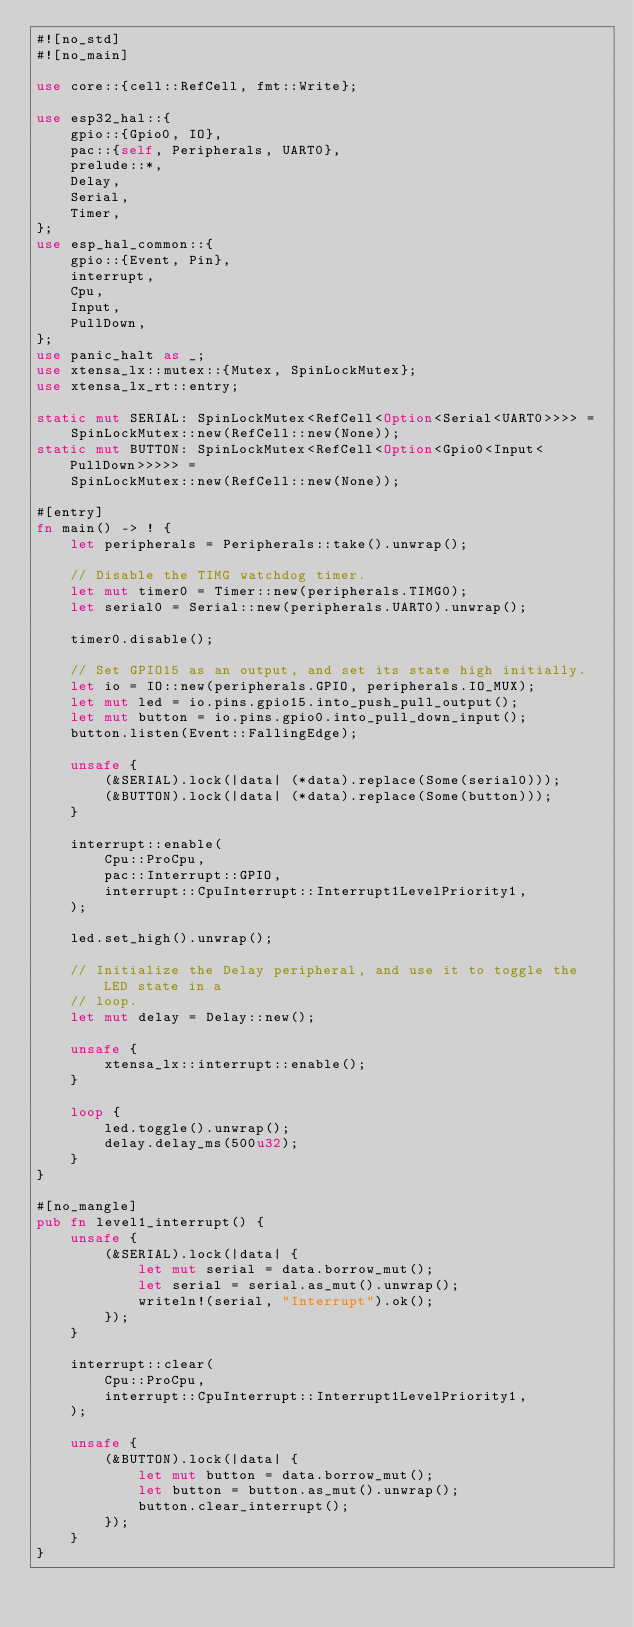<code> <loc_0><loc_0><loc_500><loc_500><_Rust_>#![no_std]
#![no_main]

use core::{cell::RefCell, fmt::Write};

use esp32_hal::{
    gpio::{Gpio0, IO},
    pac::{self, Peripherals, UART0},
    prelude::*,
    Delay,
    Serial,
    Timer,
};
use esp_hal_common::{
    gpio::{Event, Pin},
    interrupt,
    Cpu,
    Input,
    PullDown,
};
use panic_halt as _;
use xtensa_lx::mutex::{Mutex, SpinLockMutex};
use xtensa_lx_rt::entry;

static mut SERIAL: SpinLockMutex<RefCell<Option<Serial<UART0>>>> =
    SpinLockMutex::new(RefCell::new(None));
static mut BUTTON: SpinLockMutex<RefCell<Option<Gpio0<Input<PullDown>>>>> =
    SpinLockMutex::new(RefCell::new(None));

#[entry]
fn main() -> ! {
    let peripherals = Peripherals::take().unwrap();

    // Disable the TIMG watchdog timer.
    let mut timer0 = Timer::new(peripherals.TIMG0);
    let serial0 = Serial::new(peripherals.UART0).unwrap();

    timer0.disable();

    // Set GPIO15 as an output, and set its state high initially.
    let io = IO::new(peripherals.GPIO, peripherals.IO_MUX);
    let mut led = io.pins.gpio15.into_push_pull_output();
    let mut button = io.pins.gpio0.into_pull_down_input();
    button.listen(Event::FallingEdge);

    unsafe {
        (&SERIAL).lock(|data| (*data).replace(Some(serial0)));
        (&BUTTON).lock(|data| (*data).replace(Some(button)));
    }

    interrupt::enable(
        Cpu::ProCpu,
        pac::Interrupt::GPIO,
        interrupt::CpuInterrupt::Interrupt1LevelPriority1,
    );

    led.set_high().unwrap();

    // Initialize the Delay peripheral, and use it to toggle the LED state in a
    // loop.
    let mut delay = Delay::new();

    unsafe {
        xtensa_lx::interrupt::enable();
    }

    loop {
        led.toggle().unwrap();
        delay.delay_ms(500u32);
    }
}

#[no_mangle]
pub fn level1_interrupt() {
    unsafe {
        (&SERIAL).lock(|data| {
            let mut serial = data.borrow_mut();
            let serial = serial.as_mut().unwrap();
            writeln!(serial, "Interrupt").ok();
        });
    }

    interrupt::clear(
        Cpu::ProCpu,
        interrupt::CpuInterrupt::Interrupt1LevelPriority1,
    );

    unsafe {
        (&BUTTON).lock(|data| {
            let mut button = data.borrow_mut();
            let button = button.as_mut().unwrap();
            button.clear_interrupt();
        });
    }
}
</code> 